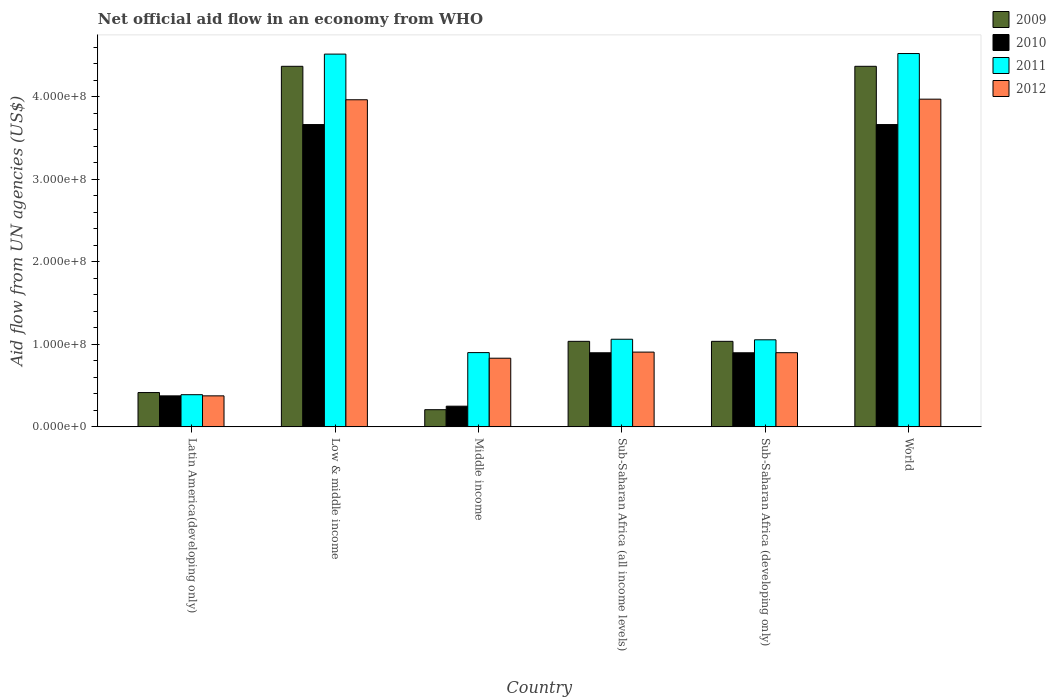How many groups of bars are there?
Offer a very short reply. 6. Are the number of bars on each tick of the X-axis equal?
Make the answer very short. Yes. How many bars are there on the 5th tick from the right?
Give a very brief answer. 4. What is the label of the 2nd group of bars from the left?
Offer a terse response. Low & middle income. In how many cases, is the number of bars for a given country not equal to the number of legend labels?
Ensure brevity in your answer.  0. What is the net official aid flow in 2010 in Sub-Saharan Africa (developing only)?
Give a very brief answer. 8.98e+07. Across all countries, what is the maximum net official aid flow in 2012?
Offer a terse response. 3.97e+08. Across all countries, what is the minimum net official aid flow in 2010?
Offer a terse response. 2.51e+07. In which country was the net official aid flow in 2009 maximum?
Offer a very short reply. Low & middle income. In which country was the net official aid flow in 2012 minimum?
Provide a succinct answer. Latin America(developing only). What is the total net official aid flow in 2011 in the graph?
Give a very brief answer. 1.24e+09. What is the difference between the net official aid flow in 2009 in Latin America(developing only) and that in Low & middle income?
Keep it short and to the point. -3.95e+08. What is the difference between the net official aid flow in 2010 in Sub-Saharan Africa (all income levels) and the net official aid flow in 2009 in Sub-Saharan Africa (developing only)?
Provide a succinct answer. -1.39e+07. What is the average net official aid flow in 2010 per country?
Keep it short and to the point. 1.62e+08. What is the difference between the net official aid flow of/in 2009 and net official aid flow of/in 2011 in Sub-Saharan Africa (developing only)?
Your answer should be compact. -1.86e+06. What is the ratio of the net official aid flow in 2009 in Middle income to that in Sub-Saharan Africa (all income levels)?
Ensure brevity in your answer.  0.2. Is the difference between the net official aid flow in 2009 in Low & middle income and Sub-Saharan Africa (all income levels) greater than the difference between the net official aid flow in 2011 in Low & middle income and Sub-Saharan Africa (all income levels)?
Your answer should be very brief. No. What is the difference between the highest and the second highest net official aid flow in 2010?
Make the answer very short. 2.76e+08. What is the difference between the highest and the lowest net official aid flow in 2010?
Give a very brief answer. 3.41e+08. Is it the case that in every country, the sum of the net official aid flow in 2012 and net official aid flow in 2009 is greater than the sum of net official aid flow in 2010 and net official aid flow in 2011?
Keep it short and to the point. No. Is it the case that in every country, the sum of the net official aid flow in 2009 and net official aid flow in 2012 is greater than the net official aid flow in 2011?
Make the answer very short. Yes. Are the values on the major ticks of Y-axis written in scientific E-notation?
Offer a terse response. Yes. Does the graph contain grids?
Provide a succinct answer. No. How many legend labels are there?
Keep it short and to the point. 4. How are the legend labels stacked?
Provide a succinct answer. Vertical. What is the title of the graph?
Your answer should be compact. Net official aid flow in an economy from WHO. Does "1997" appear as one of the legend labels in the graph?
Offer a very short reply. No. What is the label or title of the Y-axis?
Provide a short and direct response. Aid flow from UN agencies (US$). What is the Aid flow from UN agencies (US$) of 2009 in Latin America(developing only)?
Make the answer very short. 4.16e+07. What is the Aid flow from UN agencies (US$) of 2010 in Latin America(developing only)?
Keep it short and to the point. 3.76e+07. What is the Aid flow from UN agencies (US$) of 2011 in Latin America(developing only)?
Your response must be concise. 3.90e+07. What is the Aid flow from UN agencies (US$) of 2012 in Latin America(developing only)?
Ensure brevity in your answer.  3.76e+07. What is the Aid flow from UN agencies (US$) of 2009 in Low & middle income?
Offer a very short reply. 4.37e+08. What is the Aid flow from UN agencies (US$) in 2010 in Low & middle income?
Ensure brevity in your answer.  3.66e+08. What is the Aid flow from UN agencies (US$) in 2011 in Low & middle income?
Your answer should be very brief. 4.52e+08. What is the Aid flow from UN agencies (US$) of 2012 in Low & middle income?
Give a very brief answer. 3.96e+08. What is the Aid flow from UN agencies (US$) of 2009 in Middle income?
Your response must be concise. 2.08e+07. What is the Aid flow from UN agencies (US$) in 2010 in Middle income?
Provide a succinct answer. 2.51e+07. What is the Aid flow from UN agencies (US$) in 2011 in Middle income?
Ensure brevity in your answer.  9.00e+07. What is the Aid flow from UN agencies (US$) in 2012 in Middle income?
Keep it short and to the point. 8.32e+07. What is the Aid flow from UN agencies (US$) in 2009 in Sub-Saharan Africa (all income levels)?
Make the answer very short. 1.04e+08. What is the Aid flow from UN agencies (US$) in 2010 in Sub-Saharan Africa (all income levels)?
Give a very brief answer. 8.98e+07. What is the Aid flow from UN agencies (US$) of 2011 in Sub-Saharan Africa (all income levels)?
Ensure brevity in your answer.  1.06e+08. What is the Aid flow from UN agencies (US$) in 2012 in Sub-Saharan Africa (all income levels)?
Your answer should be compact. 9.06e+07. What is the Aid flow from UN agencies (US$) of 2009 in Sub-Saharan Africa (developing only)?
Your response must be concise. 1.04e+08. What is the Aid flow from UN agencies (US$) of 2010 in Sub-Saharan Africa (developing only)?
Offer a terse response. 8.98e+07. What is the Aid flow from UN agencies (US$) of 2011 in Sub-Saharan Africa (developing only)?
Offer a very short reply. 1.05e+08. What is the Aid flow from UN agencies (US$) of 2012 in Sub-Saharan Africa (developing only)?
Provide a short and direct response. 8.98e+07. What is the Aid flow from UN agencies (US$) of 2009 in World?
Ensure brevity in your answer.  4.37e+08. What is the Aid flow from UN agencies (US$) of 2010 in World?
Your answer should be compact. 3.66e+08. What is the Aid flow from UN agencies (US$) of 2011 in World?
Give a very brief answer. 4.52e+08. What is the Aid flow from UN agencies (US$) of 2012 in World?
Keep it short and to the point. 3.97e+08. Across all countries, what is the maximum Aid flow from UN agencies (US$) of 2009?
Offer a very short reply. 4.37e+08. Across all countries, what is the maximum Aid flow from UN agencies (US$) of 2010?
Keep it short and to the point. 3.66e+08. Across all countries, what is the maximum Aid flow from UN agencies (US$) in 2011?
Your answer should be compact. 4.52e+08. Across all countries, what is the maximum Aid flow from UN agencies (US$) of 2012?
Make the answer very short. 3.97e+08. Across all countries, what is the minimum Aid flow from UN agencies (US$) in 2009?
Ensure brevity in your answer.  2.08e+07. Across all countries, what is the minimum Aid flow from UN agencies (US$) of 2010?
Provide a short and direct response. 2.51e+07. Across all countries, what is the minimum Aid flow from UN agencies (US$) of 2011?
Your answer should be very brief. 3.90e+07. Across all countries, what is the minimum Aid flow from UN agencies (US$) of 2012?
Make the answer very short. 3.76e+07. What is the total Aid flow from UN agencies (US$) in 2009 in the graph?
Offer a very short reply. 1.14e+09. What is the total Aid flow from UN agencies (US$) of 2010 in the graph?
Your response must be concise. 9.75e+08. What is the total Aid flow from UN agencies (US$) in 2011 in the graph?
Keep it short and to the point. 1.24e+09. What is the total Aid flow from UN agencies (US$) of 2012 in the graph?
Make the answer very short. 1.09e+09. What is the difference between the Aid flow from UN agencies (US$) in 2009 in Latin America(developing only) and that in Low & middle income?
Your response must be concise. -3.95e+08. What is the difference between the Aid flow from UN agencies (US$) in 2010 in Latin America(developing only) and that in Low & middle income?
Keep it short and to the point. -3.29e+08. What is the difference between the Aid flow from UN agencies (US$) of 2011 in Latin America(developing only) and that in Low & middle income?
Make the answer very short. -4.13e+08. What is the difference between the Aid flow from UN agencies (US$) in 2012 in Latin America(developing only) and that in Low & middle income?
Ensure brevity in your answer.  -3.59e+08. What is the difference between the Aid flow from UN agencies (US$) of 2009 in Latin America(developing only) and that in Middle income?
Make the answer very short. 2.08e+07. What is the difference between the Aid flow from UN agencies (US$) in 2010 in Latin America(developing only) and that in Middle income?
Offer a terse response. 1.25e+07. What is the difference between the Aid flow from UN agencies (US$) in 2011 in Latin America(developing only) and that in Middle income?
Your response must be concise. -5.10e+07. What is the difference between the Aid flow from UN agencies (US$) in 2012 in Latin America(developing only) and that in Middle income?
Offer a very short reply. -4.56e+07. What is the difference between the Aid flow from UN agencies (US$) of 2009 in Latin America(developing only) and that in Sub-Saharan Africa (all income levels)?
Offer a terse response. -6.20e+07. What is the difference between the Aid flow from UN agencies (US$) in 2010 in Latin America(developing only) and that in Sub-Saharan Africa (all income levels)?
Ensure brevity in your answer.  -5.22e+07. What is the difference between the Aid flow from UN agencies (US$) in 2011 in Latin America(developing only) and that in Sub-Saharan Africa (all income levels)?
Ensure brevity in your answer.  -6.72e+07. What is the difference between the Aid flow from UN agencies (US$) in 2012 in Latin America(developing only) and that in Sub-Saharan Africa (all income levels)?
Give a very brief answer. -5.30e+07. What is the difference between the Aid flow from UN agencies (US$) in 2009 in Latin America(developing only) and that in Sub-Saharan Africa (developing only)?
Ensure brevity in your answer.  -6.20e+07. What is the difference between the Aid flow from UN agencies (US$) of 2010 in Latin America(developing only) and that in Sub-Saharan Africa (developing only)?
Your answer should be compact. -5.22e+07. What is the difference between the Aid flow from UN agencies (US$) of 2011 in Latin America(developing only) and that in Sub-Saharan Africa (developing only)?
Your answer should be very brief. -6.65e+07. What is the difference between the Aid flow from UN agencies (US$) of 2012 in Latin America(developing only) and that in Sub-Saharan Africa (developing only)?
Offer a terse response. -5.23e+07. What is the difference between the Aid flow from UN agencies (US$) in 2009 in Latin America(developing only) and that in World?
Ensure brevity in your answer.  -3.95e+08. What is the difference between the Aid flow from UN agencies (US$) in 2010 in Latin America(developing only) and that in World?
Ensure brevity in your answer.  -3.29e+08. What is the difference between the Aid flow from UN agencies (US$) of 2011 in Latin America(developing only) and that in World?
Your answer should be compact. -4.13e+08. What is the difference between the Aid flow from UN agencies (US$) of 2012 in Latin America(developing only) and that in World?
Offer a terse response. -3.59e+08. What is the difference between the Aid flow from UN agencies (US$) in 2009 in Low & middle income and that in Middle income?
Keep it short and to the point. 4.16e+08. What is the difference between the Aid flow from UN agencies (US$) of 2010 in Low & middle income and that in Middle income?
Give a very brief answer. 3.41e+08. What is the difference between the Aid flow from UN agencies (US$) in 2011 in Low & middle income and that in Middle income?
Your response must be concise. 3.62e+08. What is the difference between the Aid flow from UN agencies (US$) in 2012 in Low & middle income and that in Middle income?
Provide a short and direct response. 3.13e+08. What is the difference between the Aid flow from UN agencies (US$) of 2009 in Low & middle income and that in Sub-Saharan Africa (all income levels)?
Ensure brevity in your answer.  3.33e+08. What is the difference between the Aid flow from UN agencies (US$) of 2010 in Low & middle income and that in Sub-Saharan Africa (all income levels)?
Keep it short and to the point. 2.76e+08. What is the difference between the Aid flow from UN agencies (US$) in 2011 in Low & middle income and that in Sub-Saharan Africa (all income levels)?
Make the answer very short. 3.45e+08. What is the difference between the Aid flow from UN agencies (US$) in 2012 in Low & middle income and that in Sub-Saharan Africa (all income levels)?
Give a very brief answer. 3.06e+08. What is the difference between the Aid flow from UN agencies (US$) of 2009 in Low & middle income and that in Sub-Saharan Africa (developing only)?
Your response must be concise. 3.33e+08. What is the difference between the Aid flow from UN agencies (US$) in 2010 in Low & middle income and that in Sub-Saharan Africa (developing only)?
Offer a very short reply. 2.76e+08. What is the difference between the Aid flow from UN agencies (US$) in 2011 in Low & middle income and that in Sub-Saharan Africa (developing only)?
Give a very brief answer. 3.46e+08. What is the difference between the Aid flow from UN agencies (US$) in 2012 in Low & middle income and that in Sub-Saharan Africa (developing only)?
Provide a short and direct response. 3.06e+08. What is the difference between the Aid flow from UN agencies (US$) in 2010 in Low & middle income and that in World?
Offer a very short reply. 0. What is the difference between the Aid flow from UN agencies (US$) in 2011 in Low & middle income and that in World?
Give a very brief answer. -6.70e+05. What is the difference between the Aid flow from UN agencies (US$) of 2012 in Low & middle income and that in World?
Give a very brief answer. -7.20e+05. What is the difference between the Aid flow from UN agencies (US$) in 2009 in Middle income and that in Sub-Saharan Africa (all income levels)?
Give a very brief answer. -8.28e+07. What is the difference between the Aid flow from UN agencies (US$) of 2010 in Middle income and that in Sub-Saharan Africa (all income levels)?
Provide a succinct answer. -6.47e+07. What is the difference between the Aid flow from UN agencies (US$) in 2011 in Middle income and that in Sub-Saharan Africa (all income levels)?
Ensure brevity in your answer.  -1.62e+07. What is the difference between the Aid flow from UN agencies (US$) in 2012 in Middle income and that in Sub-Saharan Africa (all income levels)?
Offer a terse response. -7.39e+06. What is the difference between the Aid flow from UN agencies (US$) in 2009 in Middle income and that in Sub-Saharan Africa (developing only)?
Give a very brief answer. -8.28e+07. What is the difference between the Aid flow from UN agencies (US$) of 2010 in Middle income and that in Sub-Saharan Africa (developing only)?
Make the answer very short. -6.47e+07. What is the difference between the Aid flow from UN agencies (US$) in 2011 in Middle income and that in Sub-Saharan Africa (developing only)?
Make the answer very short. -1.55e+07. What is the difference between the Aid flow from UN agencies (US$) of 2012 in Middle income and that in Sub-Saharan Africa (developing only)?
Your response must be concise. -6.67e+06. What is the difference between the Aid flow from UN agencies (US$) of 2009 in Middle income and that in World?
Offer a terse response. -4.16e+08. What is the difference between the Aid flow from UN agencies (US$) of 2010 in Middle income and that in World?
Keep it short and to the point. -3.41e+08. What is the difference between the Aid flow from UN agencies (US$) of 2011 in Middle income and that in World?
Your response must be concise. -3.62e+08. What is the difference between the Aid flow from UN agencies (US$) of 2012 in Middle income and that in World?
Offer a very short reply. -3.14e+08. What is the difference between the Aid flow from UN agencies (US$) of 2009 in Sub-Saharan Africa (all income levels) and that in Sub-Saharan Africa (developing only)?
Provide a succinct answer. 0. What is the difference between the Aid flow from UN agencies (US$) in 2010 in Sub-Saharan Africa (all income levels) and that in Sub-Saharan Africa (developing only)?
Keep it short and to the point. 0. What is the difference between the Aid flow from UN agencies (US$) of 2011 in Sub-Saharan Africa (all income levels) and that in Sub-Saharan Africa (developing only)?
Your response must be concise. 6.70e+05. What is the difference between the Aid flow from UN agencies (US$) in 2012 in Sub-Saharan Africa (all income levels) and that in Sub-Saharan Africa (developing only)?
Offer a very short reply. 7.20e+05. What is the difference between the Aid flow from UN agencies (US$) of 2009 in Sub-Saharan Africa (all income levels) and that in World?
Provide a succinct answer. -3.33e+08. What is the difference between the Aid flow from UN agencies (US$) in 2010 in Sub-Saharan Africa (all income levels) and that in World?
Ensure brevity in your answer.  -2.76e+08. What is the difference between the Aid flow from UN agencies (US$) in 2011 in Sub-Saharan Africa (all income levels) and that in World?
Provide a short and direct response. -3.46e+08. What is the difference between the Aid flow from UN agencies (US$) in 2012 in Sub-Saharan Africa (all income levels) and that in World?
Your answer should be compact. -3.06e+08. What is the difference between the Aid flow from UN agencies (US$) in 2009 in Sub-Saharan Africa (developing only) and that in World?
Make the answer very short. -3.33e+08. What is the difference between the Aid flow from UN agencies (US$) in 2010 in Sub-Saharan Africa (developing only) and that in World?
Keep it short and to the point. -2.76e+08. What is the difference between the Aid flow from UN agencies (US$) of 2011 in Sub-Saharan Africa (developing only) and that in World?
Give a very brief answer. -3.47e+08. What is the difference between the Aid flow from UN agencies (US$) in 2012 in Sub-Saharan Africa (developing only) and that in World?
Provide a short and direct response. -3.07e+08. What is the difference between the Aid flow from UN agencies (US$) of 2009 in Latin America(developing only) and the Aid flow from UN agencies (US$) of 2010 in Low & middle income?
Provide a short and direct response. -3.25e+08. What is the difference between the Aid flow from UN agencies (US$) of 2009 in Latin America(developing only) and the Aid flow from UN agencies (US$) of 2011 in Low & middle income?
Offer a very short reply. -4.10e+08. What is the difference between the Aid flow from UN agencies (US$) in 2009 in Latin America(developing only) and the Aid flow from UN agencies (US$) in 2012 in Low & middle income?
Ensure brevity in your answer.  -3.55e+08. What is the difference between the Aid flow from UN agencies (US$) of 2010 in Latin America(developing only) and the Aid flow from UN agencies (US$) of 2011 in Low & middle income?
Offer a terse response. -4.14e+08. What is the difference between the Aid flow from UN agencies (US$) in 2010 in Latin America(developing only) and the Aid flow from UN agencies (US$) in 2012 in Low & middle income?
Offer a terse response. -3.59e+08. What is the difference between the Aid flow from UN agencies (US$) in 2011 in Latin America(developing only) and the Aid flow from UN agencies (US$) in 2012 in Low & middle income?
Offer a very short reply. -3.57e+08. What is the difference between the Aid flow from UN agencies (US$) in 2009 in Latin America(developing only) and the Aid flow from UN agencies (US$) in 2010 in Middle income?
Your answer should be very brief. 1.65e+07. What is the difference between the Aid flow from UN agencies (US$) of 2009 in Latin America(developing only) and the Aid flow from UN agencies (US$) of 2011 in Middle income?
Offer a very short reply. -4.84e+07. What is the difference between the Aid flow from UN agencies (US$) of 2009 in Latin America(developing only) and the Aid flow from UN agencies (US$) of 2012 in Middle income?
Offer a terse response. -4.16e+07. What is the difference between the Aid flow from UN agencies (US$) of 2010 in Latin America(developing only) and the Aid flow from UN agencies (US$) of 2011 in Middle income?
Your answer should be compact. -5.24e+07. What is the difference between the Aid flow from UN agencies (US$) of 2010 in Latin America(developing only) and the Aid flow from UN agencies (US$) of 2012 in Middle income?
Offer a terse response. -4.56e+07. What is the difference between the Aid flow from UN agencies (US$) in 2011 in Latin America(developing only) and the Aid flow from UN agencies (US$) in 2012 in Middle income?
Offer a terse response. -4.42e+07. What is the difference between the Aid flow from UN agencies (US$) of 2009 in Latin America(developing only) and the Aid flow from UN agencies (US$) of 2010 in Sub-Saharan Africa (all income levels)?
Offer a terse response. -4.82e+07. What is the difference between the Aid flow from UN agencies (US$) of 2009 in Latin America(developing only) and the Aid flow from UN agencies (US$) of 2011 in Sub-Saharan Africa (all income levels)?
Ensure brevity in your answer.  -6.46e+07. What is the difference between the Aid flow from UN agencies (US$) of 2009 in Latin America(developing only) and the Aid flow from UN agencies (US$) of 2012 in Sub-Saharan Africa (all income levels)?
Ensure brevity in your answer.  -4.90e+07. What is the difference between the Aid flow from UN agencies (US$) in 2010 in Latin America(developing only) and the Aid flow from UN agencies (US$) in 2011 in Sub-Saharan Africa (all income levels)?
Ensure brevity in your answer.  -6.86e+07. What is the difference between the Aid flow from UN agencies (US$) in 2010 in Latin America(developing only) and the Aid flow from UN agencies (US$) in 2012 in Sub-Saharan Africa (all income levels)?
Your answer should be compact. -5.30e+07. What is the difference between the Aid flow from UN agencies (US$) of 2011 in Latin America(developing only) and the Aid flow from UN agencies (US$) of 2012 in Sub-Saharan Africa (all income levels)?
Give a very brief answer. -5.16e+07. What is the difference between the Aid flow from UN agencies (US$) of 2009 in Latin America(developing only) and the Aid flow from UN agencies (US$) of 2010 in Sub-Saharan Africa (developing only)?
Provide a short and direct response. -4.82e+07. What is the difference between the Aid flow from UN agencies (US$) of 2009 in Latin America(developing only) and the Aid flow from UN agencies (US$) of 2011 in Sub-Saharan Africa (developing only)?
Your answer should be compact. -6.39e+07. What is the difference between the Aid flow from UN agencies (US$) in 2009 in Latin America(developing only) and the Aid flow from UN agencies (US$) in 2012 in Sub-Saharan Africa (developing only)?
Your response must be concise. -4.83e+07. What is the difference between the Aid flow from UN agencies (US$) in 2010 in Latin America(developing only) and the Aid flow from UN agencies (US$) in 2011 in Sub-Saharan Africa (developing only)?
Your answer should be very brief. -6.79e+07. What is the difference between the Aid flow from UN agencies (US$) of 2010 in Latin America(developing only) and the Aid flow from UN agencies (US$) of 2012 in Sub-Saharan Africa (developing only)?
Your response must be concise. -5.23e+07. What is the difference between the Aid flow from UN agencies (US$) in 2011 in Latin America(developing only) and the Aid flow from UN agencies (US$) in 2012 in Sub-Saharan Africa (developing only)?
Provide a short and direct response. -5.09e+07. What is the difference between the Aid flow from UN agencies (US$) in 2009 in Latin America(developing only) and the Aid flow from UN agencies (US$) in 2010 in World?
Your response must be concise. -3.25e+08. What is the difference between the Aid flow from UN agencies (US$) in 2009 in Latin America(developing only) and the Aid flow from UN agencies (US$) in 2011 in World?
Give a very brief answer. -4.11e+08. What is the difference between the Aid flow from UN agencies (US$) in 2009 in Latin America(developing only) and the Aid flow from UN agencies (US$) in 2012 in World?
Make the answer very short. -3.55e+08. What is the difference between the Aid flow from UN agencies (US$) of 2010 in Latin America(developing only) and the Aid flow from UN agencies (US$) of 2011 in World?
Provide a succinct answer. -4.15e+08. What is the difference between the Aid flow from UN agencies (US$) of 2010 in Latin America(developing only) and the Aid flow from UN agencies (US$) of 2012 in World?
Ensure brevity in your answer.  -3.59e+08. What is the difference between the Aid flow from UN agencies (US$) of 2011 in Latin America(developing only) and the Aid flow from UN agencies (US$) of 2012 in World?
Offer a very short reply. -3.58e+08. What is the difference between the Aid flow from UN agencies (US$) in 2009 in Low & middle income and the Aid flow from UN agencies (US$) in 2010 in Middle income?
Your answer should be compact. 4.12e+08. What is the difference between the Aid flow from UN agencies (US$) in 2009 in Low & middle income and the Aid flow from UN agencies (US$) in 2011 in Middle income?
Provide a short and direct response. 3.47e+08. What is the difference between the Aid flow from UN agencies (US$) of 2009 in Low & middle income and the Aid flow from UN agencies (US$) of 2012 in Middle income?
Make the answer very short. 3.54e+08. What is the difference between the Aid flow from UN agencies (US$) in 2010 in Low & middle income and the Aid flow from UN agencies (US$) in 2011 in Middle income?
Offer a very short reply. 2.76e+08. What is the difference between the Aid flow from UN agencies (US$) of 2010 in Low & middle income and the Aid flow from UN agencies (US$) of 2012 in Middle income?
Ensure brevity in your answer.  2.83e+08. What is the difference between the Aid flow from UN agencies (US$) in 2011 in Low & middle income and the Aid flow from UN agencies (US$) in 2012 in Middle income?
Keep it short and to the point. 3.68e+08. What is the difference between the Aid flow from UN agencies (US$) of 2009 in Low & middle income and the Aid flow from UN agencies (US$) of 2010 in Sub-Saharan Africa (all income levels)?
Offer a very short reply. 3.47e+08. What is the difference between the Aid flow from UN agencies (US$) in 2009 in Low & middle income and the Aid flow from UN agencies (US$) in 2011 in Sub-Saharan Africa (all income levels)?
Make the answer very short. 3.31e+08. What is the difference between the Aid flow from UN agencies (US$) in 2009 in Low & middle income and the Aid flow from UN agencies (US$) in 2012 in Sub-Saharan Africa (all income levels)?
Provide a succinct answer. 3.46e+08. What is the difference between the Aid flow from UN agencies (US$) in 2010 in Low & middle income and the Aid flow from UN agencies (US$) in 2011 in Sub-Saharan Africa (all income levels)?
Your answer should be very brief. 2.60e+08. What is the difference between the Aid flow from UN agencies (US$) of 2010 in Low & middle income and the Aid flow from UN agencies (US$) of 2012 in Sub-Saharan Africa (all income levels)?
Your response must be concise. 2.76e+08. What is the difference between the Aid flow from UN agencies (US$) of 2011 in Low & middle income and the Aid flow from UN agencies (US$) of 2012 in Sub-Saharan Africa (all income levels)?
Provide a short and direct response. 3.61e+08. What is the difference between the Aid flow from UN agencies (US$) of 2009 in Low & middle income and the Aid flow from UN agencies (US$) of 2010 in Sub-Saharan Africa (developing only)?
Your answer should be very brief. 3.47e+08. What is the difference between the Aid flow from UN agencies (US$) in 2009 in Low & middle income and the Aid flow from UN agencies (US$) in 2011 in Sub-Saharan Africa (developing only)?
Make the answer very short. 3.31e+08. What is the difference between the Aid flow from UN agencies (US$) of 2009 in Low & middle income and the Aid flow from UN agencies (US$) of 2012 in Sub-Saharan Africa (developing only)?
Keep it short and to the point. 3.47e+08. What is the difference between the Aid flow from UN agencies (US$) in 2010 in Low & middle income and the Aid flow from UN agencies (US$) in 2011 in Sub-Saharan Africa (developing only)?
Offer a terse response. 2.61e+08. What is the difference between the Aid flow from UN agencies (US$) in 2010 in Low & middle income and the Aid flow from UN agencies (US$) in 2012 in Sub-Saharan Africa (developing only)?
Provide a short and direct response. 2.76e+08. What is the difference between the Aid flow from UN agencies (US$) in 2011 in Low & middle income and the Aid flow from UN agencies (US$) in 2012 in Sub-Saharan Africa (developing only)?
Ensure brevity in your answer.  3.62e+08. What is the difference between the Aid flow from UN agencies (US$) of 2009 in Low & middle income and the Aid flow from UN agencies (US$) of 2010 in World?
Keep it short and to the point. 7.06e+07. What is the difference between the Aid flow from UN agencies (US$) in 2009 in Low & middle income and the Aid flow from UN agencies (US$) in 2011 in World?
Offer a very short reply. -1.55e+07. What is the difference between the Aid flow from UN agencies (US$) in 2009 in Low & middle income and the Aid flow from UN agencies (US$) in 2012 in World?
Provide a succinct answer. 3.98e+07. What is the difference between the Aid flow from UN agencies (US$) of 2010 in Low & middle income and the Aid flow from UN agencies (US$) of 2011 in World?
Provide a succinct answer. -8.60e+07. What is the difference between the Aid flow from UN agencies (US$) in 2010 in Low & middle income and the Aid flow from UN agencies (US$) in 2012 in World?
Provide a short and direct response. -3.08e+07. What is the difference between the Aid flow from UN agencies (US$) of 2011 in Low & middle income and the Aid flow from UN agencies (US$) of 2012 in World?
Offer a very short reply. 5.46e+07. What is the difference between the Aid flow from UN agencies (US$) in 2009 in Middle income and the Aid flow from UN agencies (US$) in 2010 in Sub-Saharan Africa (all income levels)?
Keep it short and to the point. -6.90e+07. What is the difference between the Aid flow from UN agencies (US$) of 2009 in Middle income and the Aid flow from UN agencies (US$) of 2011 in Sub-Saharan Africa (all income levels)?
Provide a succinct answer. -8.54e+07. What is the difference between the Aid flow from UN agencies (US$) of 2009 in Middle income and the Aid flow from UN agencies (US$) of 2012 in Sub-Saharan Africa (all income levels)?
Keep it short and to the point. -6.98e+07. What is the difference between the Aid flow from UN agencies (US$) of 2010 in Middle income and the Aid flow from UN agencies (US$) of 2011 in Sub-Saharan Africa (all income levels)?
Give a very brief answer. -8.11e+07. What is the difference between the Aid flow from UN agencies (US$) of 2010 in Middle income and the Aid flow from UN agencies (US$) of 2012 in Sub-Saharan Africa (all income levels)?
Keep it short and to the point. -6.55e+07. What is the difference between the Aid flow from UN agencies (US$) of 2011 in Middle income and the Aid flow from UN agencies (US$) of 2012 in Sub-Saharan Africa (all income levels)?
Provide a succinct answer. -5.90e+05. What is the difference between the Aid flow from UN agencies (US$) of 2009 in Middle income and the Aid flow from UN agencies (US$) of 2010 in Sub-Saharan Africa (developing only)?
Keep it short and to the point. -6.90e+07. What is the difference between the Aid flow from UN agencies (US$) of 2009 in Middle income and the Aid flow from UN agencies (US$) of 2011 in Sub-Saharan Africa (developing only)?
Offer a very short reply. -8.47e+07. What is the difference between the Aid flow from UN agencies (US$) in 2009 in Middle income and the Aid flow from UN agencies (US$) in 2012 in Sub-Saharan Africa (developing only)?
Ensure brevity in your answer.  -6.90e+07. What is the difference between the Aid flow from UN agencies (US$) in 2010 in Middle income and the Aid flow from UN agencies (US$) in 2011 in Sub-Saharan Africa (developing only)?
Provide a short and direct response. -8.04e+07. What is the difference between the Aid flow from UN agencies (US$) in 2010 in Middle income and the Aid flow from UN agencies (US$) in 2012 in Sub-Saharan Africa (developing only)?
Keep it short and to the point. -6.48e+07. What is the difference between the Aid flow from UN agencies (US$) of 2009 in Middle income and the Aid flow from UN agencies (US$) of 2010 in World?
Offer a terse response. -3.45e+08. What is the difference between the Aid flow from UN agencies (US$) of 2009 in Middle income and the Aid flow from UN agencies (US$) of 2011 in World?
Make the answer very short. -4.31e+08. What is the difference between the Aid flow from UN agencies (US$) of 2009 in Middle income and the Aid flow from UN agencies (US$) of 2012 in World?
Your answer should be compact. -3.76e+08. What is the difference between the Aid flow from UN agencies (US$) of 2010 in Middle income and the Aid flow from UN agencies (US$) of 2011 in World?
Offer a terse response. -4.27e+08. What is the difference between the Aid flow from UN agencies (US$) in 2010 in Middle income and the Aid flow from UN agencies (US$) in 2012 in World?
Offer a terse response. -3.72e+08. What is the difference between the Aid flow from UN agencies (US$) in 2011 in Middle income and the Aid flow from UN agencies (US$) in 2012 in World?
Your response must be concise. -3.07e+08. What is the difference between the Aid flow from UN agencies (US$) in 2009 in Sub-Saharan Africa (all income levels) and the Aid flow from UN agencies (US$) in 2010 in Sub-Saharan Africa (developing only)?
Offer a very short reply. 1.39e+07. What is the difference between the Aid flow from UN agencies (US$) in 2009 in Sub-Saharan Africa (all income levels) and the Aid flow from UN agencies (US$) in 2011 in Sub-Saharan Africa (developing only)?
Keep it short and to the point. -1.86e+06. What is the difference between the Aid flow from UN agencies (US$) in 2009 in Sub-Saharan Africa (all income levels) and the Aid flow from UN agencies (US$) in 2012 in Sub-Saharan Africa (developing only)?
Provide a succinct answer. 1.38e+07. What is the difference between the Aid flow from UN agencies (US$) in 2010 in Sub-Saharan Africa (all income levels) and the Aid flow from UN agencies (US$) in 2011 in Sub-Saharan Africa (developing only)?
Give a very brief answer. -1.57e+07. What is the difference between the Aid flow from UN agencies (US$) in 2010 in Sub-Saharan Africa (all income levels) and the Aid flow from UN agencies (US$) in 2012 in Sub-Saharan Africa (developing only)?
Provide a short and direct response. -9.00e+04. What is the difference between the Aid flow from UN agencies (US$) in 2011 in Sub-Saharan Africa (all income levels) and the Aid flow from UN agencies (US$) in 2012 in Sub-Saharan Africa (developing only)?
Make the answer very short. 1.63e+07. What is the difference between the Aid flow from UN agencies (US$) of 2009 in Sub-Saharan Africa (all income levels) and the Aid flow from UN agencies (US$) of 2010 in World?
Keep it short and to the point. -2.63e+08. What is the difference between the Aid flow from UN agencies (US$) of 2009 in Sub-Saharan Africa (all income levels) and the Aid flow from UN agencies (US$) of 2011 in World?
Give a very brief answer. -3.49e+08. What is the difference between the Aid flow from UN agencies (US$) in 2009 in Sub-Saharan Africa (all income levels) and the Aid flow from UN agencies (US$) in 2012 in World?
Provide a succinct answer. -2.93e+08. What is the difference between the Aid flow from UN agencies (US$) in 2010 in Sub-Saharan Africa (all income levels) and the Aid flow from UN agencies (US$) in 2011 in World?
Your answer should be compact. -3.62e+08. What is the difference between the Aid flow from UN agencies (US$) of 2010 in Sub-Saharan Africa (all income levels) and the Aid flow from UN agencies (US$) of 2012 in World?
Offer a terse response. -3.07e+08. What is the difference between the Aid flow from UN agencies (US$) of 2011 in Sub-Saharan Africa (all income levels) and the Aid flow from UN agencies (US$) of 2012 in World?
Provide a succinct answer. -2.91e+08. What is the difference between the Aid flow from UN agencies (US$) in 2009 in Sub-Saharan Africa (developing only) and the Aid flow from UN agencies (US$) in 2010 in World?
Provide a short and direct response. -2.63e+08. What is the difference between the Aid flow from UN agencies (US$) of 2009 in Sub-Saharan Africa (developing only) and the Aid flow from UN agencies (US$) of 2011 in World?
Provide a short and direct response. -3.49e+08. What is the difference between the Aid flow from UN agencies (US$) of 2009 in Sub-Saharan Africa (developing only) and the Aid flow from UN agencies (US$) of 2012 in World?
Provide a short and direct response. -2.93e+08. What is the difference between the Aid flow from UN agencies (US$) of 2010 in Sub-Saharan Africa (developing only) and the Aid flow from UN agencies (US$) of 2011 in World?
Offer a terse response. -3.62e+08. What is the difference between the Aid flow from UN agencies (US$) in 2010 in Sub-Saharan Africa (developing only) and the Aid flow from UN agencies (US$) in 2012 in World?
Make the answer very short. -3.07e+08. What is the difference between the Aid flow from UN agencies (US$) of 2011 in Sub-Saharan Africa (developing only) and the Aid flow from UN agencies (US$) of 2012 in World?
Keep it short and to the point. -2.92e+08. What is the average Aid flow from UN agencies (US$) in 2009 per country?
Offer a terse response. 1.91e+08. What is the average Aid flow from UN agencies (US$) of 2010 per country?
Give a very brief answer. 1.62e+08. What is the average Aid flow from UN agencies (US$) of 2011 per country?
Provide a short and direct response. 2.07e+08. What is the average Aid flow from UN agencies (US$) of 2012 per country?
Offer a very short reply. 1.82e+08. What is the difference between the Aid flow from UN agencies (US$) in 2009 and Aid flow from UN agencies (US$) in 2010 in Latin America(developing only)?
Keep it short and to the point. 4.01e+06. What is the difference between the Aid flow from UN agencies (US$) in 2009 and Aid flow from UN agencies (US$) in 2011 in Latin America(developing only)?
Offer a terse response. 2.59e+06. What is the difference between the Aid flow from UN agencies (US$) of 2009 and Aid flow from UN agencies (US$) of 2012 in Latin America(developing only)?
Offer a terse response. 3.99e+06. What is the difference between the Aid flow from UN agencies (US$) in 2010 and Aid flow from UN agencies (US$) in 2011 in Latin America(developing only)?
Your answer should be very brief. -1.42e+06. What is the difference between the Aid flow from UN agencies (US$) of 2010 and Aid flow from UN agencies (US$) of 2012 in Latin America(developing only)?
Your answer should be compact. -2.00e+04. What is the difference between the Aid flow from UN agencies (US$) in 2011 and Aid flow from UN agencies (US$) in 2012 in Latin America(developing only)?
Your response must be concise. 1.40e+06. What is the difference between the Aid flow from UN agencies (US$) in 2009 and Aid flow from UN agencies (US$) in 2010 in Low & middle income?
Ensure brevity in your answer.  7.06e+07. What is the difference between the Aid flow from UN agencies (US$) of 2009 and Aid flow from UN agencies (US$) of 2011 in Low & middle income?
Provide a succinct answer. -1.48e+07. What is the difference between the Aid flow from UN agencies (US$) in 2009 and Aid flow from UN agencies (US$) in 2012 in Low & middle income?
Make the answer very short. 4.05e+07. What is the difference between the Aid flow from UN agencies (US$) of 2010 and Aid flow from UN agencies (US$) of 2011 in Low & middle income?
Offer a terse response. -8.54e+07. What is the difference between the Aid flow from UN agencies (US$) of 2010 and Aid flow from UN agencies (US$) of 2012 in Low & middle income?
Provide a succinct answer. -3.00e+07. What is the difference between the Aid flow from UN agencies (US$) of 2011 and Aid flow from UN agencies (US$) of 2012 in Low & middle income?
Offer a terse response. 5.53e+07. What is the difference between the Aid flow from UN agencies (US$) of 2009 and Aid flow from UN agencies (US$) of 2010 in Middle income?
Provide a succinct answer. -4.27e+06. What is the difference between the Aid flow from UN agencies (US$) in 2009 and Aid flow from UN agencies (US$) in 2011 in Middle income?
Your response must be concise. -6.92e+07. What is the difference between the Aid flow from UN agencies (US$) in 2009 and Aid flow from UN agencies (US$) in 2012 in Middle income?
Offer a terse response. -6.24e+07. What is the difference between the Aid flow from UN agencies (US$) of 2010 and Aid flow from UN agencies (US$) of 2011 in Middle income?
Ensure brevity in your answer.  -6.49e+07. What is the difference between the Aid flow from UN agencies (US$) in 2010 and Aid flow from UN agencies (US$) in 2012 in Middle income?
Your response must be concise. -5.81e+07. What is the difference between the Aid flow from UN agencies (US$) in 2011 and Aid flow from UN agencies (US$) in 2012 in Middle income?
Make the answer very short. 6.80e+06. What is the difference between the Aid flow from UN agencies (US$) of 2009 and Aid flow from UN agencies (US$) of 2010 in Sub-Saharan Africa (all income levels)?
Your answer should be compact. 1.39e+07. What is the difference between the Aid flow from UN agencies (US$) of 2009 and Aid flow from UN agencies (US$) of 2011 in Sub-Saharan Africa (all income levels)?
Provide a short and direct response. -2.53e+06. What is the difference between the Aid flow from UN agencies (US$) of 2009 and Aid flow from UN agencies (US$) of 2012 in Sub-Saharan Africa (all income levels)?
Your answer should be compact. 1.30e+07. What is the difference between the Aid flow from UN agencies (US$) of 2010 and Aid flow from UN agencies (US$) of 2011 in Sub-Saharan Africa (all income levels)?
Give a very brief answer. -1.64e+07. What is the difference between the Aid flow from UN agencies (US$) of 2010 and Aid flow from UN agencies (US$) of 2012 in Sub-Saharan Africa (all income levels)?
Your answer should be compact. -8.10e+05. What is the difference between the Aid flow from UN agencies (US$) in 2011 and Aid flow from UN agencies (US$) in 2012 in Sub-Saharan Africa (all income levels)?
Offer a very short reply. 1.56e+07. What is the difference between the Aid flow from UN agencies (US$) in 2009 and Aid flow from UN agencies (US$) in 2010 in Sub-Saharan Africa (developing only)?
Provide a succinct answer. 1.39e+07. What is the difference between the Aid flow from UN agencies (US$) in 2009 and Aid flow from UN agencies (US$) in 2011 in Sub-Saharan Africa (developing only)?
Offer a terse response. -1.86e+06. What is the difference between the Aid flow from UN agencies (US$) of 2009 and Aid flow from UN agencies (US$) of 2012 in Sub-Saharan Africa (developing only)?
Your answer should be compact. 1.38e+07. What is the difference between the Aid flow from UN agencies (US$) in 2010 and Aid flow from UN agencies (US$) in 2011 in Sub-Saharan Africa (developing only)?
Your answer should be compact. -1.57e+07. What is the difference between the Aid flow from UN agencies (US$) of 2010 and Aid flow from UN agencies (US$) of 2012 in Sub-Saharan Africa (developing only)?
Your answer should be compact. -9.00e+04. What is the difference between the Aid flow from UN agencies (US$) of 2011 and Aid flow from UN agencies (US$) of 2012 in Sub-Saharan Africa (developing only)?
Offer a very short reply. 1.56e+07. What is the difference between the Aid flow from UN agencies (US$) of 2009 and Aid flow from UN agencies (US$) of 2010 in World?
Ensure brevity in your answer.  7.06e+07. What is the difference between the Aid flow from UN agencies (US$) of 2009 and Aid flow from UN agencies (US$) of 2011 in World?
Offer a terse response. -1.55e+07. What is the difference between the Aid flow from UN agencies (US$) in 2009 and Aid flow from UN agencies (US$) in 2012 in World?
Offer a very short reply. 3.98e+07. What is the difference between the Aid flow from UN agencies (US$) in 2010 and Aid flow from UN agencies (US$) in 2011 in World?
Your answer should be very brief. -8.60e+07. What is the difference between the Aid flow from UN agencies (US$) in 2010 and Aid flow from UN agencies (US$) in 2012 in World?
Your response must be concise. -3.08e+07. What is the difference between the Aid flow from UN agencies (US$) in 2011 and Aid flow from UN agencies (US$) in 2012 in World?
Give a very brief answer. 5.53e+07. What is the ratio of the Aid flow from UN agencies (US$) of 2009 in Latin America(developing only) to that in Low & middle income?
Keep it short and to the point. 0.1. What is the ratio of the Aid flow from UN agencies (US$) in 2010 in Latin America(developing only) to that in Low & middle income?
Offer a terse response. 0.1. What is the ratio of the Aid flow from UN agencies (US$) in 2011 in Latin America(developing only) to that in Low & middle income?
Offer a very short reply. 0.09. What is the ratio of the Aid flow from UN agencies (US$) of 2012 in Latin America(developing only) to that in Low & middle income?
Offer a terse response. 0.09. What is the ratio of the Aid flow from UN agencies (US$) of 2009 in Latin America(developing only) to that in Middle income?
Your answer should be compact. 2. What is the ratio of the Aid flow from UN agencies (US$) in 2010 in Latin America(developing only) to that in Middle income?
Ensure brevity in your answer.  1.5. What is the ratio of the Aid flow from UN agencies (US$) in 2011 in Latin America(developing only) to that in Middle income?
Make the answer very short. 0.43. What is the ratio of the Aid flow from UN agencies (US$) in 2012 in Latin America(developing only) to that in Middle income?
Your answer should be compact. 0.45. What is the ratio of the Aid flow from UN agencies (US$) in 2009 in Latin America(developing only) to that in Sub-Saharan Africa (all income levels)?
Give a very brief answer. 0.4. What is the ratio of the Aid flow from UN agencies (US$) of 2010 in Latin America(developing only) to that in Sub-Saharan Africa (all income levels)?
Your response must be concise. 0.42. What is the ratio of the Aid flow from UN agencies (US$) in 2011 in Latin America(developing only) to that in Sub-Saharan Africa (all income levels)?
Provide a short and direct response. 0.37. What is the ratio of the Aid flow from UN agencies (US$) in 2012 in Latin America(developing only) to that in Sub-Saharan Africa (all income levels)?
Provide a short and direct response. 0.41. What is the ratio of the Aid flow from UN agencies (US$) in 2009 in Latin America(developing only) to that in Sub-Saharan Africa (developing only)?
Make the answer very short. 0.4. What is the ratio of the Aid flow from UN agencies (US$) in 2010 in Latin America(developing only) to that in Sub-Saharan Africa (developing only)?
Offer a terse response. 0.42. What is the ratio of the Aid flow from UN agencies (US$) of 2011 in Latin America(developing only) to that in Sub-Saharan Africa (developing only)?
Provide a succinct answer. 0.37. What is the ratio of the Aid flow from UN agencies (US$) of 2012 in Latin America(developing only) to that in Sub-Saharan Africa (developing only)?
Keep it short and to the point. 0.42. What is the ratio of the Aid flow from UN agencies (US$) in 2009 in Latin America(developing only) to that in World?
Provide a succinct answer. 0.1. What is the ratio of the Aid flow from UN agencies (US$) in 2010 in Latin America(developing only) to that in World?
Offer a terse response. 0.1. What is the ratio of the Aid flow from UN agencies (US$) in 2011 in Latin America(developing only) to that in World?
Provide a short and direct response. 0.09. What is the ratio of the Aid flow from UN agencies (US$) in 2012 in Latin America(developing only) to that in World?
Make the answer very short. 0.09. What is the ratio of the Aid flow from UN agencies (US$) of 2009 in Low & middle income to that in Middle income?
Your answer should be compact. 21. What is the ratio of the Aid flow from UN agencies (US$) in 2010 in Low & middle income to that in Middle income?
Keep it short and to the point. 14.61. What is the ratio of the Aid flow from UN agencies (US$) of 2011 in Low & middle income to that in Middle income?
Your response must be concise. 5.02. What is the ratio of the Aid flow from UN agencies (US$) in 2012 in Low & middle income to that in Middle income?
Ensure brevity in your answer.  4.76. What is the ratio of the Aid flow from UN agencies (US$) of 2009 in Low & middle income to that in Sub-Saharan Africa (all income levels)?
Your answer should be compact. 4.22. What is the ratio of the Aid flow from UN agencies (US$) of 2010 in Low & middle income to that in Sub-Saharan Africa (all income levels)?
Your answer should be very brief. 4.08. What is the ratio of the Aid flow from UN agencies (US$) of 2011 in Low & middle income to that in Sub-Saharan Africa (all income levels)?
Offer a terse response. 4.25. What is the ratio of the Aid flow from UN agencies (US$) of 2012 in Low & middle income to that in Sub-Saharan Africa (all income levels)?
Offer a terse response. 4.38. What is the ratio of the Aid flow from UN agencies (US$) in 2009 in Low & middle income to that in Sub-Saharan Africa (developing only)?
Your response must be concise. 4.22. What is the ratio of the Aid flow from UN agencies (US$) of 2010 in Low & middle income to that in Sub-Saharan Africa (developing only)?
Your response must be concise. 4.08. What is the ratio of the Aid flow from UN agencies (US$) of 2011 in Low & middle income to that in Sub-Saharan Africa (developing only)?
Keep it short and to the point. 4.28. What is the ratio of the Aid flow from UN agencies (US$) in 2012 in Low & middle income to that in Sub-Saharan Africa (developing only)?
Your response must be concise. 4.41. What is the ratio of the Aid flow from UN agencies (US$) in 2009 in Low & middle income to that in World?
Your answer should be compact. 1. What is the ratio of the Aid flow from UN agencies (US$) of 2009 in Middle income to that in Sub-Saharan Africa (all income levels)?
Your answer should be very brief. 0.2. What is the ratio of the Aid flow from UN agencies (US$) in 2010 in Middle income to that in Sub-Saharan Africa (all income levels)?
Offer a very short reply. 0.28. What is the ratio of the Aid flow from UN agencies (US$) in 2011 in Middle income to that in Sub-Saharan Africa (all income levels)?
Offer a very short reply. 0.85. What is the ratio of the Aid flow from UN agencies (US$) of 2012 in Middle income to that in Sub-Saharan Africa (all income levels)?
Your answer should be compact. 0.92. What is the ratio of the Aid flow from UN agencies (US$) in 2009 in Middle income to that in Sub-Saharan Africa (developing only)?
Provide a short and direct response. 0.2. What is the ratio of the Aid flow from UN agencies (US$) of 2010 in Middle income to that in Sub-Saharan Africa (developing only)?
Make the answer very short. 0.28. What is the ratio of the Aid flow from UN agencies (US$) in 2011 in Middle income to that in Sub-Saharan Africa (developing only)?
Your answer should be very brief. 0.85. What is the ratio of the Aid flow from UN agencies (US$) in 2012 in Middle income to that in Sub-Saharan Africa (developing only)?
Provide a succinct answer. 0.93. What is the ratio of the Aid flow from UN agencies (US$) in 2009 in Middle income to that in World?
Your response must be concise. 0.05. What is the ratio of the Aid flow from UN agencies (US$) in 2010 in Middle income to that in World?
Provide a short and direct response. 0.07. What is the ratio of the Aid flow from UN agencies (US$) of 2011 in Middle income to that in World?
Provide a succinct answer. 0.2. What is the ratio of the Aid flow from UN agencies (US$) of 2012 in Middle income to that in World?
Provide a short and direct response. 0.21. What is the ratio of the Aid flow from UN agencies (US$) of 2011 in Sub-Saharan Africa (all income levels) to that in Sub-Saharan Africa (developing only)?
Your response must be concise. 1.01. What is the ratio of the Aid flow from UN agencies (US$) in 2012 in Sub-Saharan Africa (all income levels) to that in Sub-Saharan Africa (developing only)?
Offer a terse response. 1.01. What is the ratio of the Aid flow from UN agencies (US$) of 2009 in Sub-Saharan Africa (all income levels) to that in World?
Your answer should be very brief. 0.24. What is the ratio of the Aid flow from UN agencies (US$) in 2010 in Sub-Saharan Africa (all income levels) to that in World?
Make the answer very short. 0.25. What is the ratio of the Aid flow from UN agencies (US$) in 2011 in Sub-Saharan Africa (all income levels) to that in World?
Your answer should be compact. 0.23. What is the ratio of the Aid flow from UN agencies (US$) in 2012 in Sub-Saharan Africa (all income levels) to that in World?
Give a very brief answer. 0.23. What is the ratio of the Aid flow from UN agencies (US$) in 2009 in Sub-Saharan Africa (developing only) to that in World?
Your answer should be very brief. 0.24. What is the ratio of the Aid flow from UN agencies (US$) of 2010 in Sub-Saharan Africa (developing only) to that in World?
Your answer should be very brief. 0.25. What is the ratio of the Aid flow from UN agencies (US$) in 2011 in Sub-Saharan Africa (developing only) to that in World?
Your answer should be compact. 0.23. What is the ratio of the Aid flow from UN agencies (US$) of 2012 in Sub-Saharan Africa (developing only) to that in World?
Your answer should be very brief. 0.23. What is the difference between the highest and the second highest Aid flow from UN agencies (US$) of 2009?
Your answer should be very brief. 0. What is the difference between the highest and the second highest Aid flow from UN agencies (US$) of 2010?
Your answer should be very brief. 0. What is the difference between the highest and the second highest Aid flow from UN agencies (US$) in 2011?
Give a very brief answer. 6.70e+05. What is the difference between the highest and the second highest Aid flow from UN agencies (US$) of 2012?
Keep it short and to the point. 7.20e+05. What is the difference between the highest and the lowest Aid flow from UN agencies (US$) in 2009?
Your answer should be compact. 4.16e+08. What is the difference between the highest and the lowest Aid flow from UN agencies (US$) of 2010?
Make the answer very short. 3.41e+08. What is the difference between the highest and the lowest Aid flow from UN agencies (US$) of 2011?
Provide a short and direct response. 4.13e+08. What is the difference between the highest and the lowest Aid flow from UN agencies (US$) of 2012?
Give a very brief answer. 3.59e+08. 